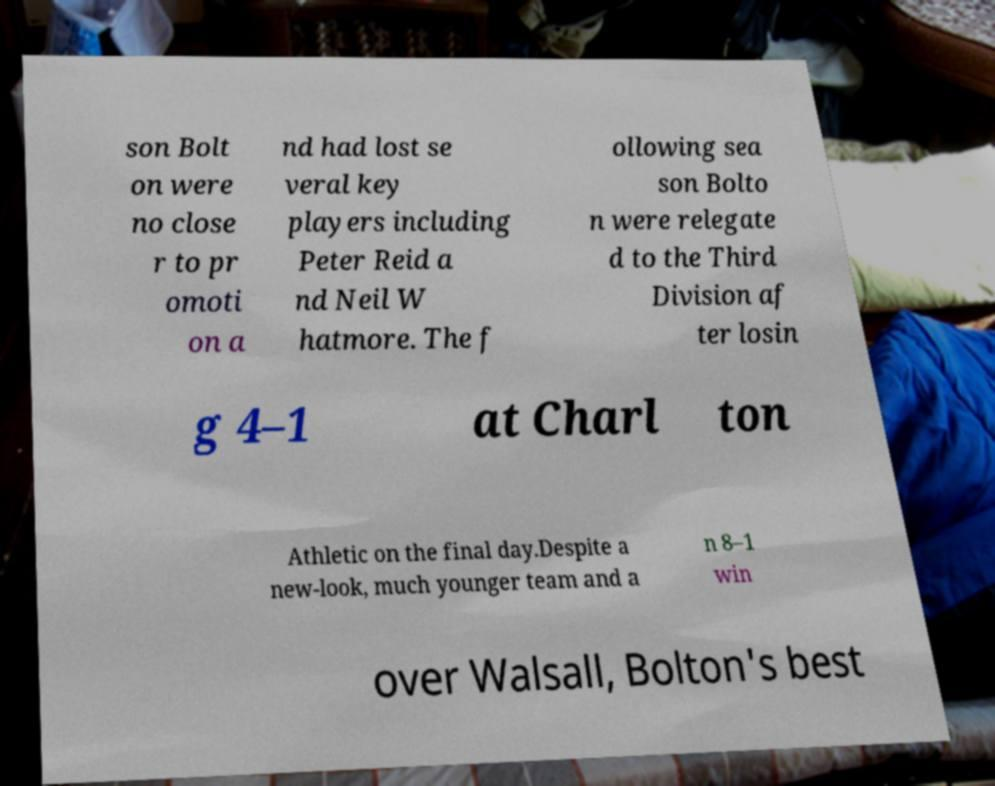For documentation purposes, I need the text within this image transcribed. Could you provide that? son Bolt on were no close r to pr omoti on a nd had lost se veral key players including Peter Reid a nd Neil W hatmore. The f ollowing sea son Bolto n were relegate d to the Third Division af ter losin g 4–1 at Charl ton Athletic on the final day.Despite a new-look, much younger team and a n 8–1 win over Walsall, Bolton's best 